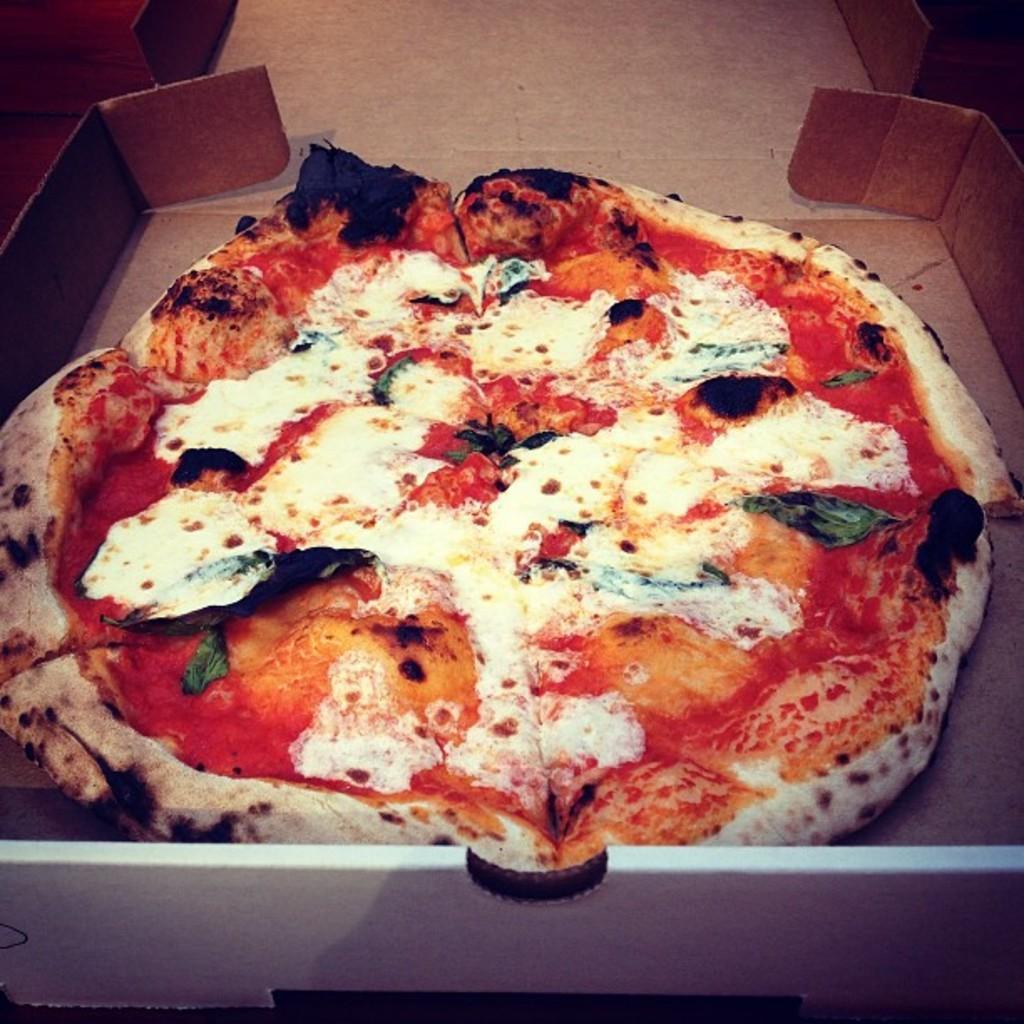Could you give a brief overview of what you see in this image? In this image I can see a pizza in a box. 